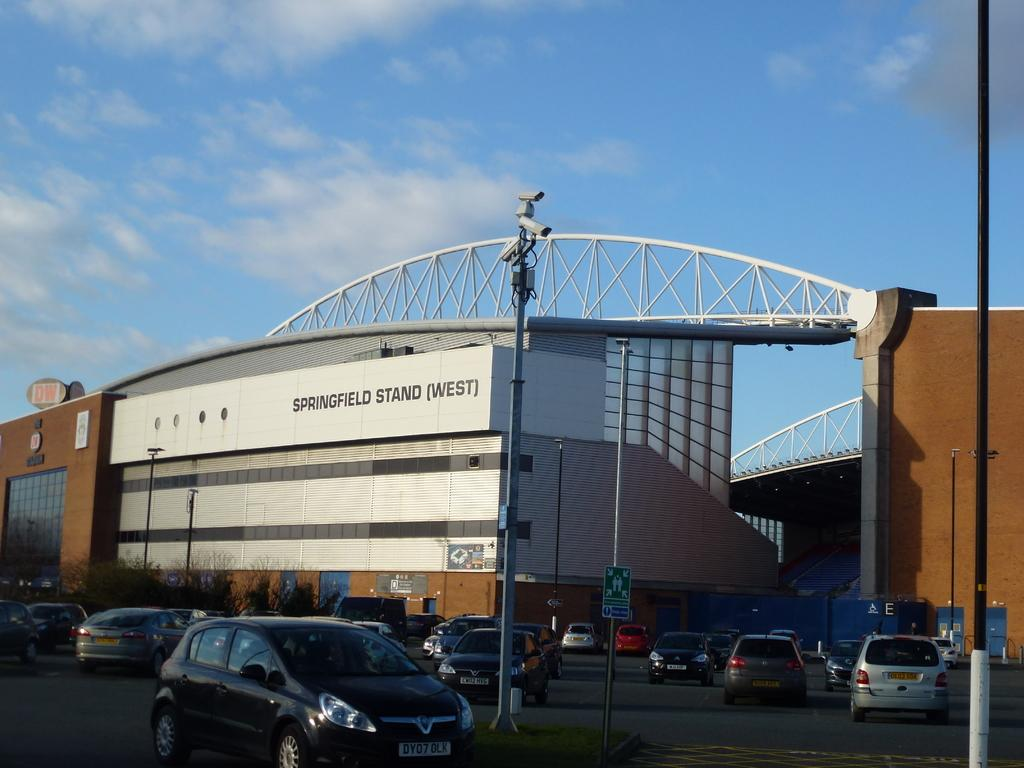What is the main feature of the image? There is a road in the image. What is happening on the road? There are vehicles on the road. What else can be seen in the image besides the road and vehicles? There are poles, boards, cameras, trees, and a huge building in the background of the image. The sky is also visible in the background. What type of celery is being used to direct traffic in the image? There is no celery present in the image, and it is not being used to direct traffic. 